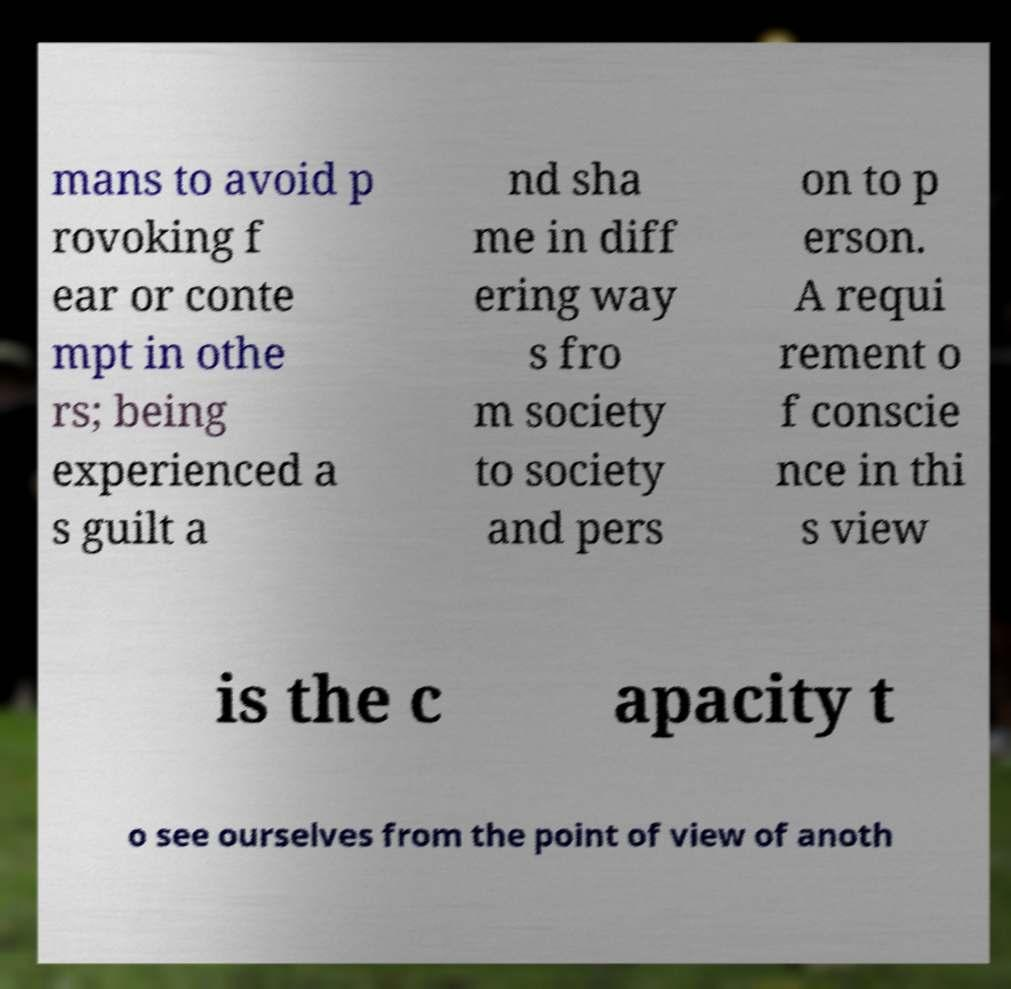I need the written content from this picture converted into text. Can you do that? mans to avoid p rovoking f ear or conte mpt in othe rs; being experienced a s guilt a nd sha me in diff ering way s fro m society to society and pers on to p erson. A requi rement o f conscie nce in thi s view is the c apacity t o see ourselves from the point of view of anoth 